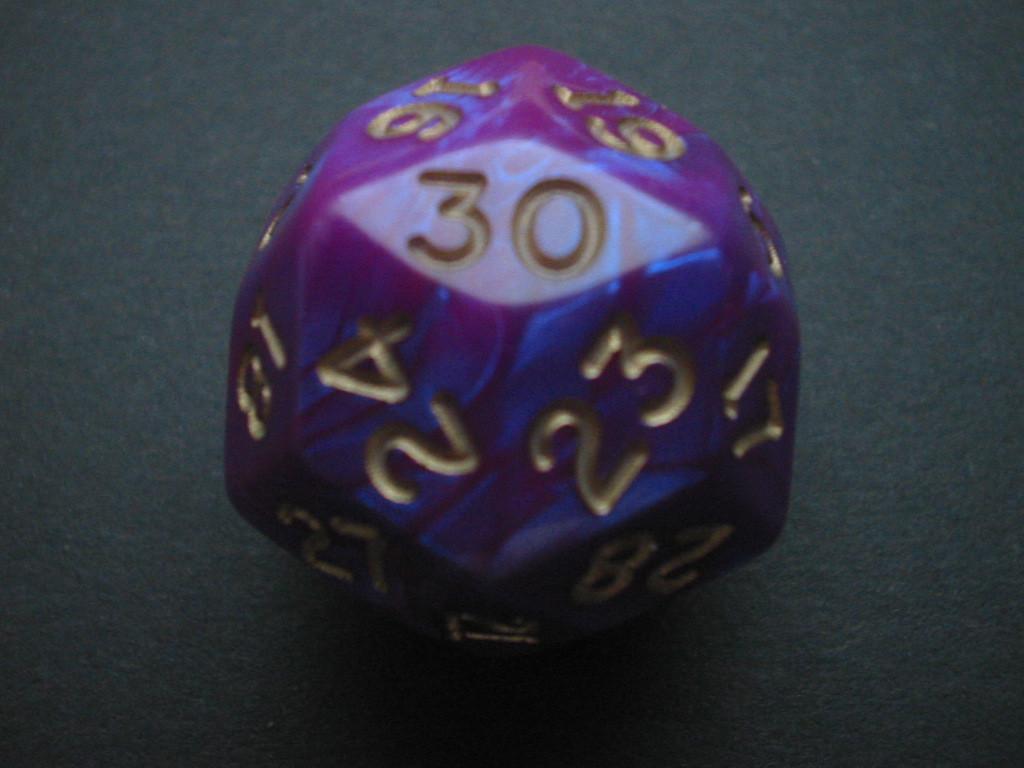Please provide a concise description of this image. In this image, we can see dice with numbers on the surface. 